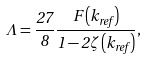Convert formula to latex. <formula><loc_0><loc_0><loc_500><loc_500>\Lambda = \frac { 2 7 } { 8 } \frac { F \left ( k _ { r e f } \right ) } { 1 - 2 \zeta \left ( k _ { r e f } \right ) } ,</formula> 